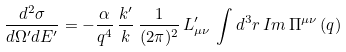Convert formula to latex. <formula><loc_0><loc_0><loc_500><loc_500>\frac { d ^ { 2 } \sigma } { d \Omega ^ { \prime } d E ^ { \prime } } = - \frac { \alpha } { q ^ { 4 } } \, \frac { k ^ { \prime } } { k } \, \frac { 1 } { ( 2 \pi ) ^ { 2 } } \, L ^ { \prime } _ { \mu \nu } \, \int d ^ { 3 } r \, I m \, \Pi ^ { \mu \nu } \, ( q )</formula> 